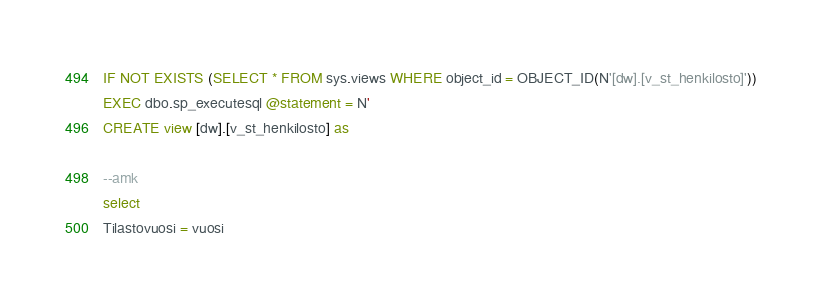Convert code to text. <code><loc_0><loc_0><loc_500><loc_500><_SQL_>IF NOT EXISTS (SELECT * FROM sys.views WHERE object_id = OBJECT_ID(N'[dw].[v_st_henkilosto]'))
EXEC dbo.sp_executesql @statement = N'
CREATE view [dw].[v_st_henkilosto] as

--amk
select 
Tilastovuosi = vuosi
</code> 